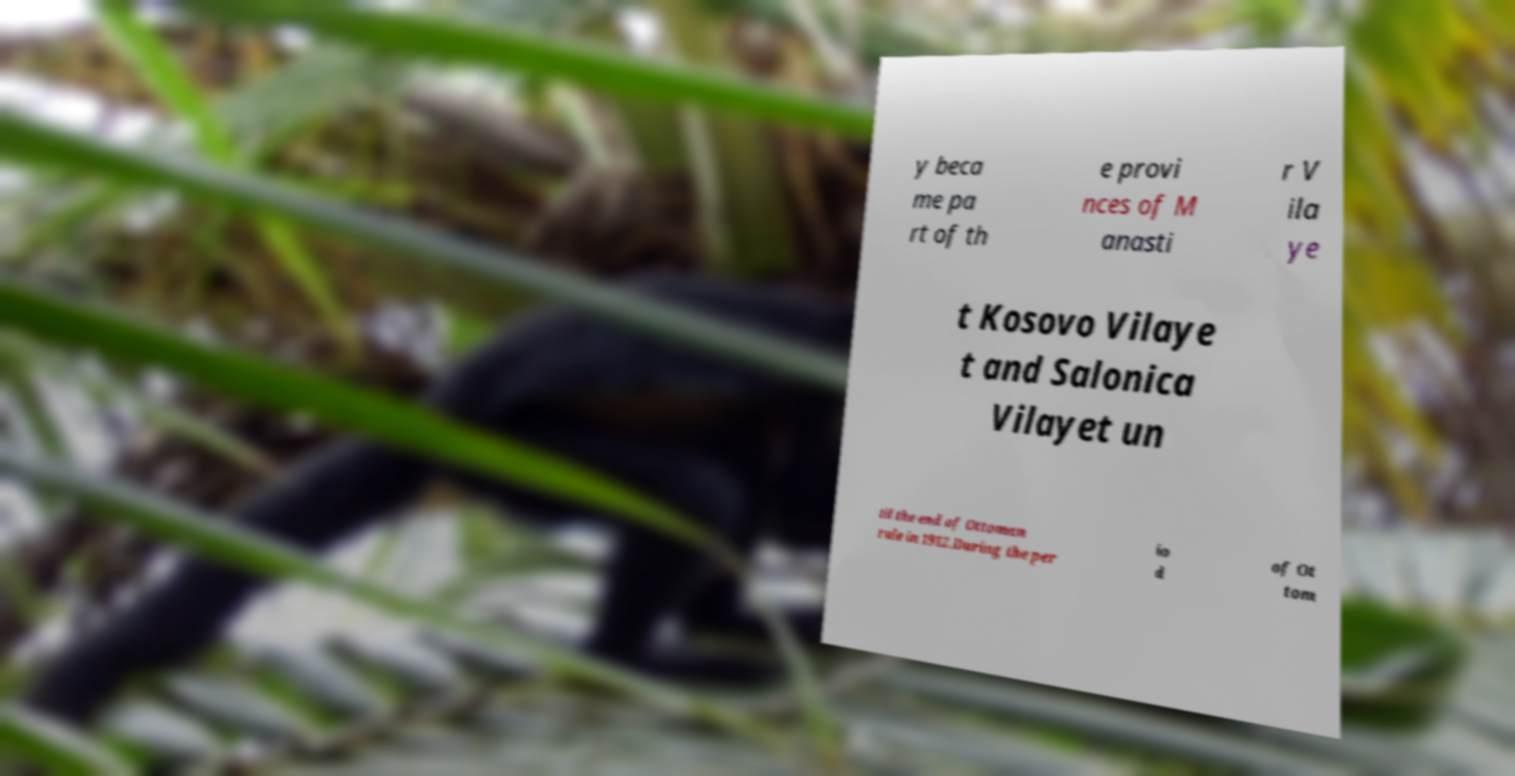Can you accurately transcribe the text from the provided image for me? y beca me pa rt of th e provi nces of M anasti r V ila ye t Kosovo Vilaye t and Salonica Vilayet un til the end of Ottoman rule in 1912.During the per io d of Ot tom 